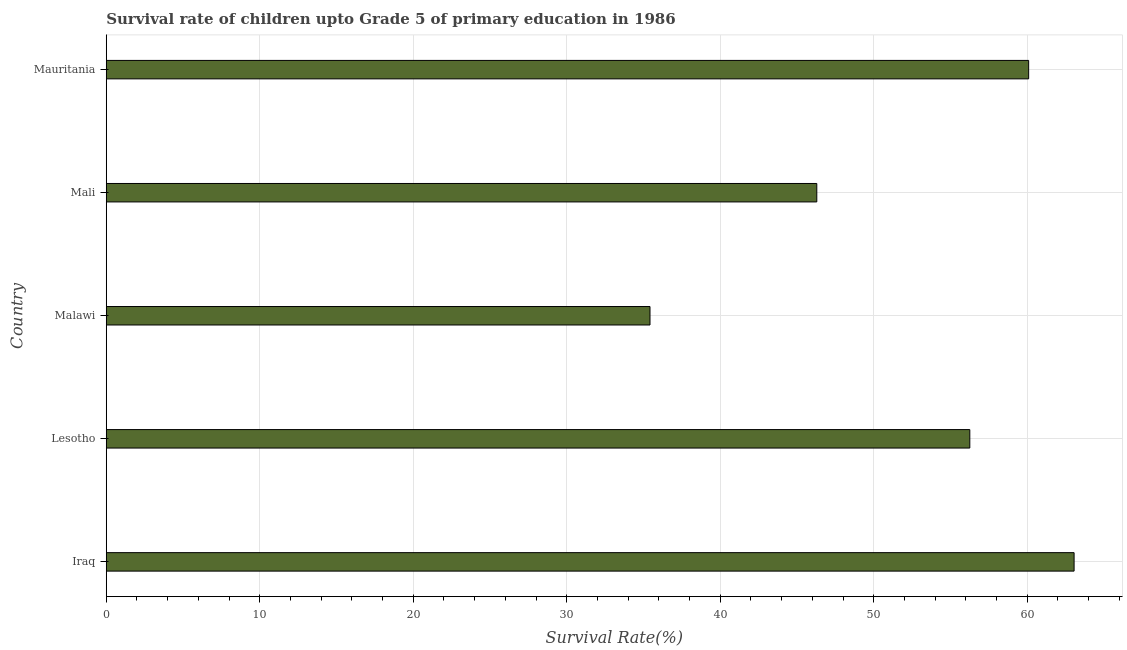Does the graph contain any zero values?
Keep it short and to the point. No. Does the graph contain grids?
Offer a very short reply. Yes. What is the title of the graph?
Give a very brief answer. Survival rate of children upto Grade 5 of primary education in 1986 . What is the label or title of the X-axis?
Offer a very short reply. Survival Rate(%). What is the label or title of the Y-axis?
Your answer should be very brief. Country. What is the survival rate in Iraq?
Provide a succinct answer. 63.05. Across all countries, what is the maximum survival rate?
Give a very brief answer. 63.05. Across all countries, what is the minimum survival rate?
Give a very brief answer. 35.43. In which country was the survival rate maximum?
Keep it short and to the point. Iraq. In which country was the survival rate minimum?
Your response must be concise. Malawi. What is the sum of the survival rate?
Offer a terse response. 261.13. What is the difference between the survival rate in Lesotho and Mauritania?
Offer a terse response. -3.83. What is the average survival rate per country?
Your response must be concise. 52.23. What is the median survival rate?
Your answer should be compact. 56.26. In how many countries, is the survival rate greater than 38 %?
Provide a short and direct response. 4. What is the ratio of the survival rate in Malawi to that in Mauritania?
Your response must be concise. 0.59. Is the survival rate in Malawi less than that in Mali?
Your response must be concise. Yes. What is the difference between the highest and the second highest survival rate?
Offer a very short reply. 2.96. Is the sum of the survival rate in Lesotho and Mali greater than the maximum survival rate across all countries?
Give a very brief answer. Yes. What is the difference between the highest and the lowest survival rate?
Provide a succinct answer. 27.63. In how many countries, is the survival rate greater than the average survival rate taken over all countries?
Give a very brief answer. 3. Are the values on the major ticks of X-axis written in scientific E-notation?
Offer a terse response. No. What is the Survival Rate(%) of Iraq?
Your answer should be compact. 63.05. What is the Survival Rate(%) in Lesotho?
Keep it short and to the point. 56.26. What is the Survival Rate(%) in Malawi?
Keep it short and to the point. 35.43. What is the Survival Rate(%) in Mali?
Make the answer very short. 46.29. What is the Survival Rate(%) in Mauritania?
Your answer should be compact. 60.09. What is the difference between the Survival Rate(%) in Iraq and Lesotho?
Make the answer very short. 6.79. What is the difference between the Survival Rate(%) in Iraq and Malawi?
Your response must be concise. 27.63. What is the difference between the Survival Rate(%) in Iraq and Mali?
Your answer should be compact. 16.76. What is the difference between the Survival Rate(%) in Iraq and Mauritania?
Your answer should be compact. 2.96. What is the difference between the Survival Rate(%) in Lesotho and Malawi?
Provide a succinct answer. 20.84. What is the difference between the Survival Rate(%) in Lesotho and Mali?
Provide a short and direct response. 9.97. What is the difference between the Survival Rate(%) in Lesotho and Mauritania?
Provide a succinct answer. -3.83. What is the difference between the Survival Rate(%) in Malawi and Mali?
Offer a terse response. -10.87. What is the difference between the Survival Rate(%) in Malawi and Mauritania?
Provide a short and direct response. -24.67. What is the difference between the Survival Rate(%) in Mali and Mauritania?
Give a very brief answer. -13.8. What is the ratio of the Survival Rate(%) in Iraq to that in Lesotho?
Keep it short and to the point. 1.12. What is the ratio of the Survival Rate(%) in Iraq to that in Malawi?
Ensure brevity in your answer.  1.78. What is the ratio of the Survival Rate(%) in Iraq to that in Mali?
Ensure brevity in your answer.  1.36. What is the ratio of the Survival Rate(%) in Iraq to that in Mauritania?
Provide a short and direct response. 1.05. What is the ratio of the Survival Rate(%) in Lesotho to that in Malawi?
Make the answer very short. 1.59. What is the ratio of the Survival Rate(%) in Lesotho to that in Mali?
Your answer should be compact. 1.22. What is the ratio of the Survival Rate(%) in Lesotho to that in Mauritania?
Offer a very short reply. 0.94. What is the ratio of the Survival Rate(%) in Malawi to that in Mali?
Your answer should be compact. 0.77. What is the ratio of the Survival Rate(%) in Malawi to that in Mauritania?
Give a very brief answer. 0.59. What is the ratio of the Survival Rate(%) in Mali to that in Mauritania?
Make the answer very short. 0.77. 